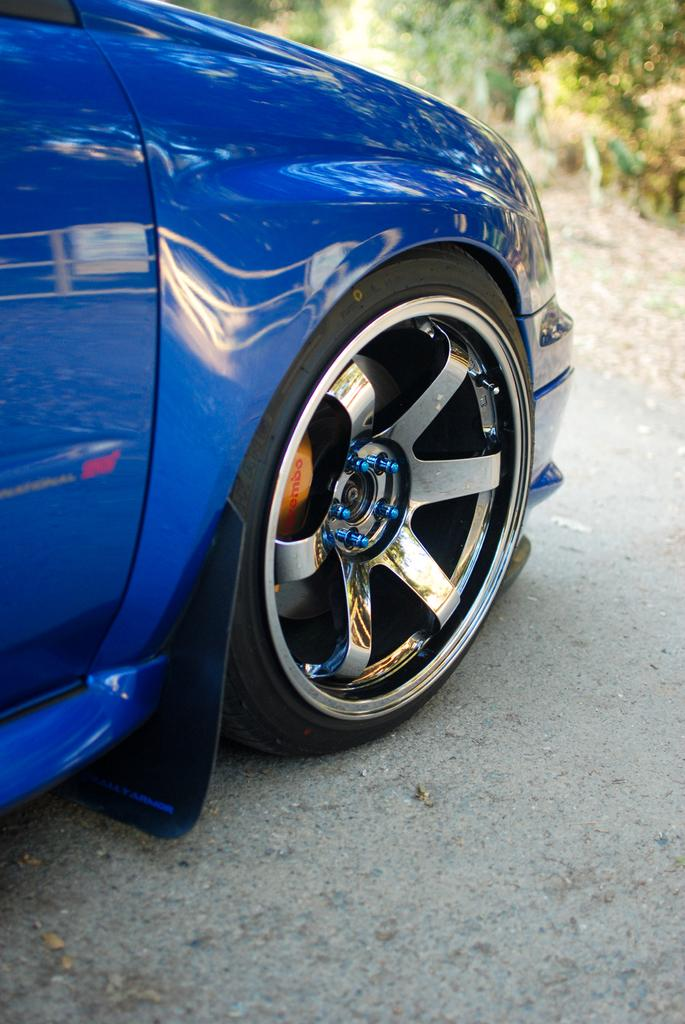What color is the car in the image? The car in the image is blue. Where is the car located in the image? The car is placed on the road. What can be seen in the background of the image? There are trees visible in the background of the image. What is visible at the bottom of the image? The road is visible at the bottom of the image. How does the car increase the thrill in the downtown area in the image? The image does not depict a downtown area, nor does it show any indication of increased thrill. The car is simply placed on the road with trees visible in the background. 